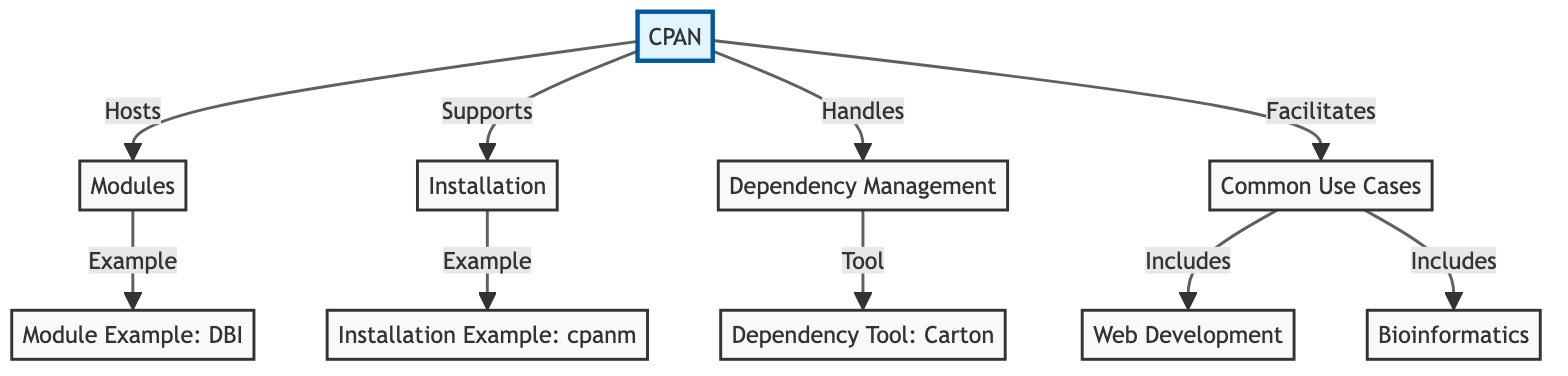What does CPAN host? The diagram indicates that CPAN hosts modules, which is shown by the directed edge from CPAN to the Modules node labeled "Hosts".
Answer: Modules What is an example of a module under CPAN? According to the diagram, "Module Example: DBI" is provided as an example of a module, highlighted by the direct connection from the Modules node to this example node.
Answer: DBI Which tool is mentioned for dependency management? The diagram features "Dependency Tool: Carton" as a specified tool for managing dependencies, shown by the connection from the Dependency Management node to this tool node.
Answer: Carton How many common use cases are listed? There are two use cases mentioned in the diagram: Web Development and Bioinformatics, indicated by the connections from the Use Cases node leading to both specific examples.
Answer: 2 What does CPAN facilitate? The directed edge from CPAN to the Use Cases node indicates that CPAN facilitates use cases, as stated in the labeled relation on the diagram.
Answer: Use Cases What kind of installation does CPAN support? The diagram states that CPAN supports installation, reflected by the edge connecting CPAN to the Installation node, which directly answers the type of activity CPAN is involved in.
Answer: Installation Which example is given for installation methods? The installation example provided in the diagram is "Installation Example: cpanm", which is highlighted through the connection from the Installation node to this example.
Answer: cpanm What are the two included common use cases? The diagram shows that the common use cases include Web Development and Bioinformatics, as indicated by the arrows leading from the Use Cases node to both specific examples.
Answer: Web Development, Bioinformatics 